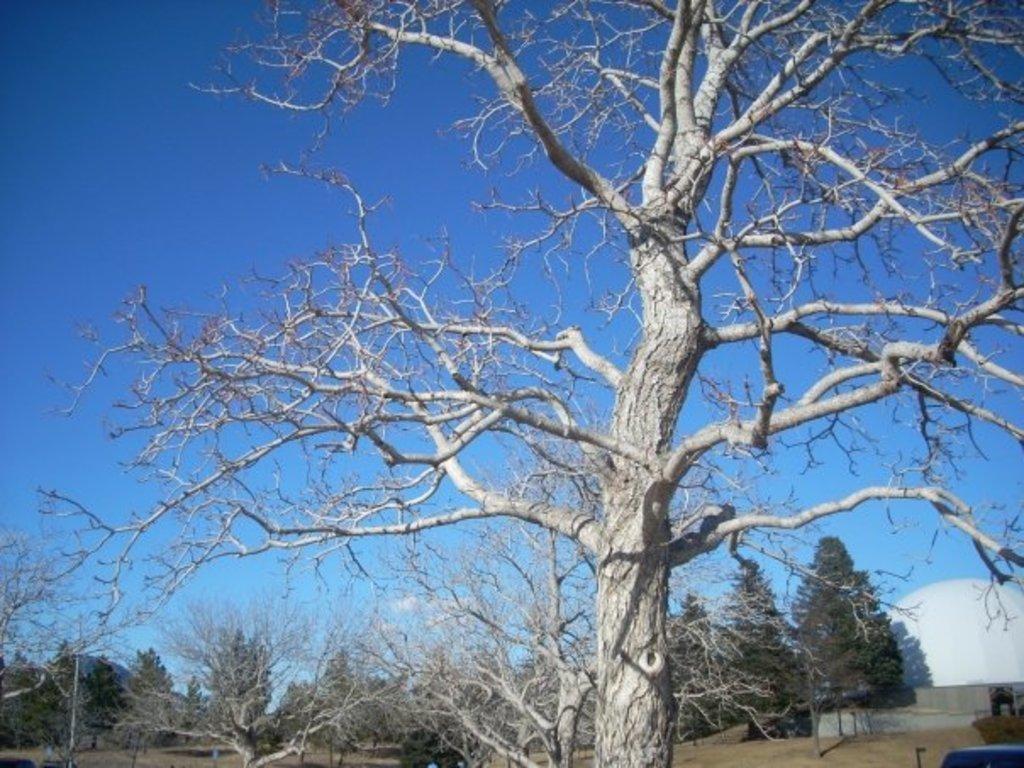Could you give a brief overview of what you see in this image? In this image we can see trees. In the background there is a dome shaped architecture and also there is sky. 